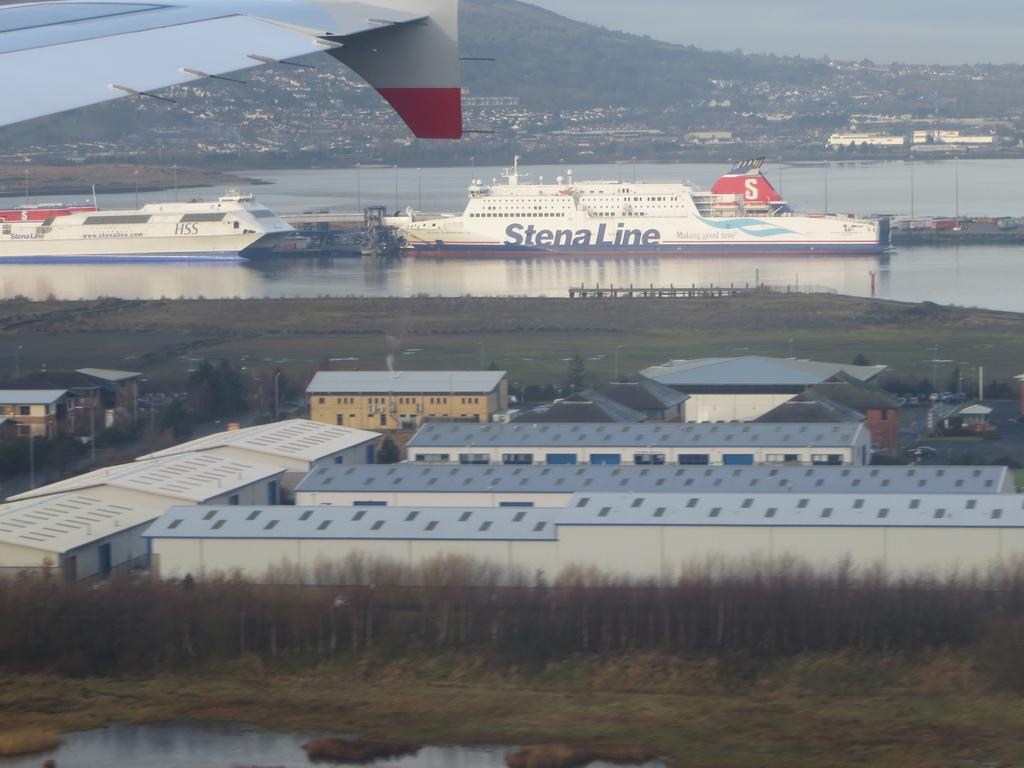<image>
Relay a brief, clear account of the picture shown. The large Stena Line boat can be seen from land coming into the harbour. 